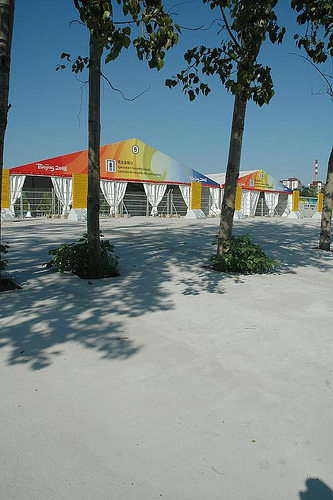<image>
Is the tree in the building? No. The tree is not contained within the building. These objects have a different spatial relationship. 